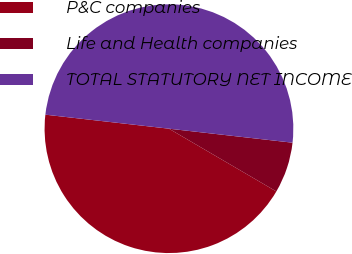<chart> <loc_0><loc_0><loc_500><loc_500><pie_chart><fcel>P&C companies<fcel>Life and Health companies<fcel>TOTAL STATUTORY NET INCOME<nl><fcel>43.38%<fcel>6.62%<fcel>50.0%<nl></chart> 